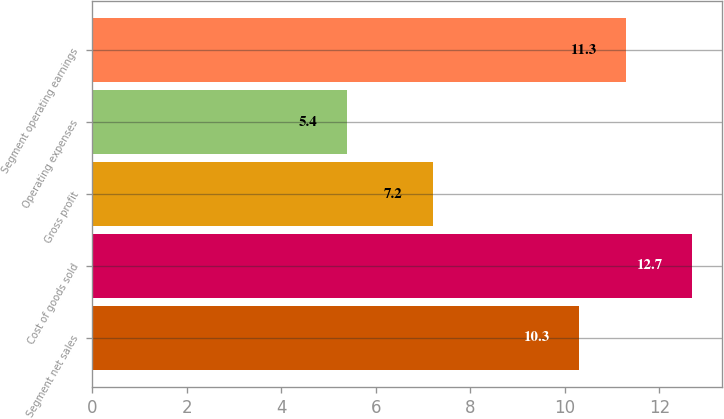Convert chart. <chart><loc_0><loc_0><loc_500><loc_500><bar_chart><fcel>Segment net sales<fcel>Cost of goods sold<fcel>Gross profit<fcel>Operating expenses<fcel>Segment operating earnings<nl><fcel>10.3<fcel>12.7<fcel>7.2<fcel>5.4<fcel>11.3<nl></chart> 